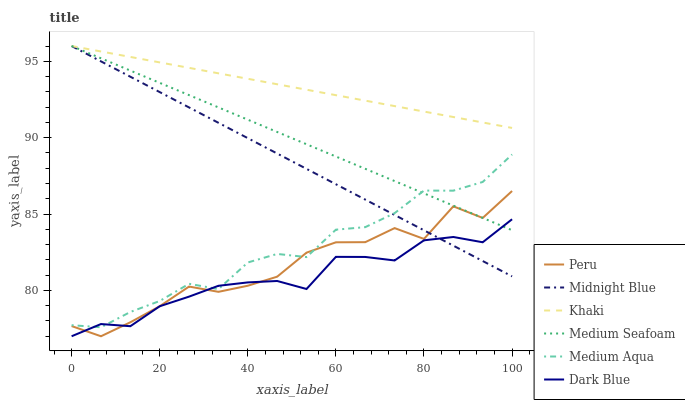Does Dark Blue have the minimum area under the curve?
Answer yes or no. Yes. Does Khaki have the maximum area under the curve?
Answer yes or no. Yes. Does Midnight Blue have the minimum area under the curve?
Answer yes or no. No. Does Midnight Blue have the maximum area under the curve?
Answer yes or no. No. Is Medium Seafoam the smoothest?
Answer yes or no. Yes. Is Peru the roughest?
Answer yes or no. Yes. Is Midnight Blue the smoothest?
Answer yes or no. No. Is Midnight Blue the roughest?
Answer yes or no. No. Does Dark Blue have the lowest value?
Answer yes or no. Yes. Does Midnight Blue have the lowest value?
Answer yes or no. No. Does Medium Seafoam have the highest value?
Answer yes or no. Yes. Does Dark Blue have the highest value?
Answer yes or no. No. Is Peru less than Khaki?
Answer yes or no. Yes. Is Khaki greater than Dark Blue?
Answer yes or no. Yes. Does Medium Seafoam intersect Medium Aqua?
Answer yes or no. Yes. Is Medium Seafoam less than Medium Aqua?
Answer yes or no. No. Is Medium Seafoam greater than Medium Aqua?
Answer yes or no. No. Does Peru intersect Khaki?
Answer yes or no. No. 